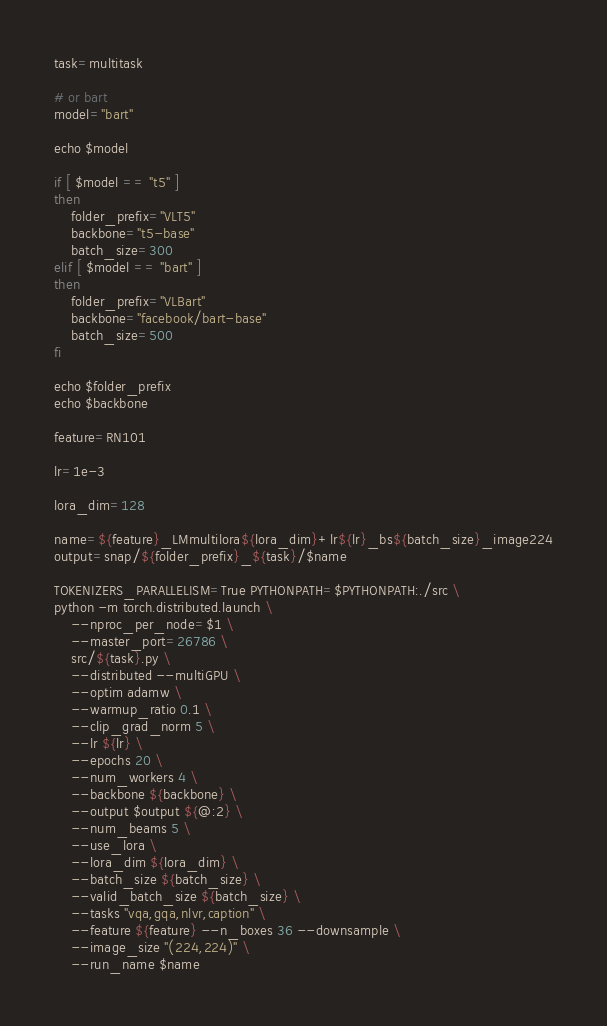Convert code to text. <code><loc_0><loc_0><loc_500><loc_500><_Bash_>task=multitask

# or bart
model="bart"

echo $model

if [ $model == "t5" ]
then
    folder_prefix="VLT5"
    backbone="t5-base"
    batch_size=300
elif [ $model == "bart" ]
then
    folder_prefix="VLBart"
    backbone="facebook/bart-base"
    batch_size=500
fi

echo $folder_prefix
echo $backbone

feature=RN101

lr=1e-3

lora_dim=128

name=${feature}_LMmultilora${lora_dim}+lr${lr}_bs${batch_size}_image224
output=snap/${folder_prefix}_${task}/$name

TOKENIZERS_PARALLELISM=True PYTHONPATH=$PYTHONPATH:./src \
python -m torch.distributed.launch \
    --nproc_per_node=$1 \
    --master_port=26786 \
    src/${task}.py \
    --distributed --multiGPU \
    --optim adamw \
    --warmup_ratio 0.1 \
    --clip_grad_norm 5 \
    --lr ${lr} \
    --epochs 20 \
    --num_workers 4 \
    --backbone ${backbone} \
    --output $output ${@:2} \
    --num_beams 5 \
    --use_lora \
    --lora_dim ${lora_dim} \
    --batch_size ${batch_size} \
    --valid_batch_size ${batch_size} \
    --tasks "vqa,gqa,nlvr,caption" \
    --feature ${feature} --n_boxes 36 --downsample \
    --image_size "(224,224)" \
    --run_name $name
</code> 